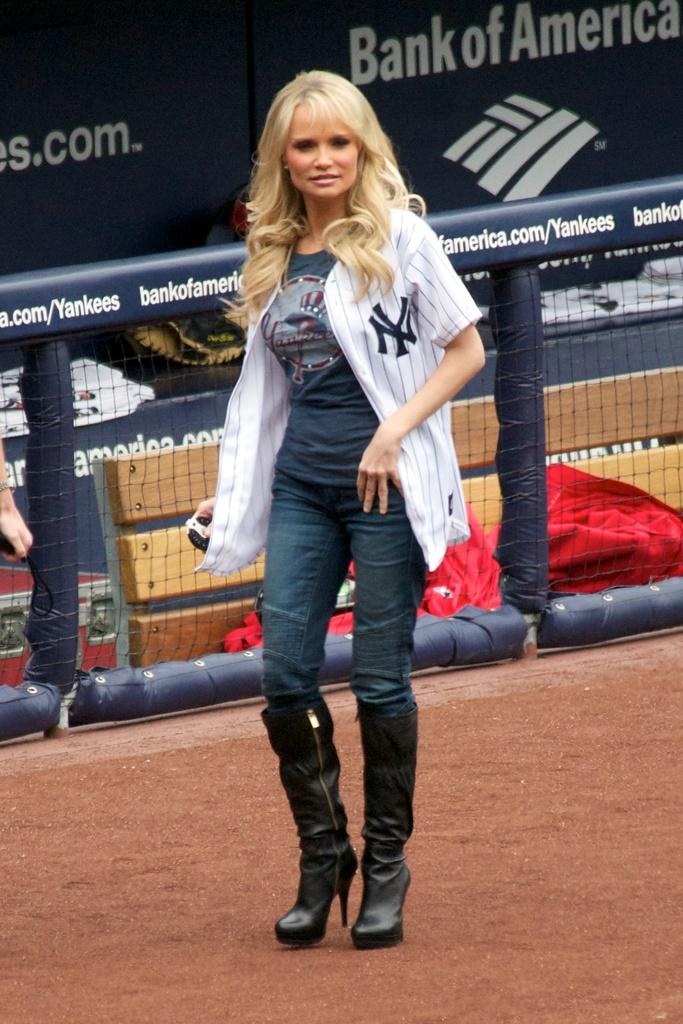Provide a one-sentence caption for the provided image. THE DUGOUT HAS BANK OF AMERICA AS A SPONSER. 